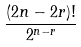<formula> <loc_0><loc_0><loc_500><loc_500>\frac { ( 2 n - 2 r ) ! } { 2 ^ { n - r } }</formula> 